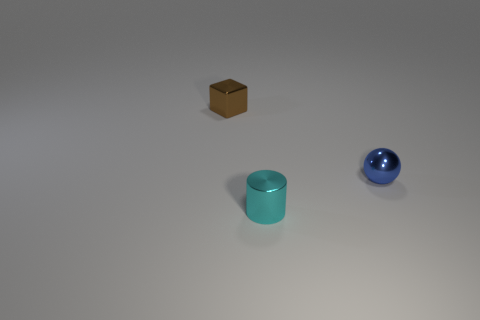How many blocks are either tiny red shiny things or cyan shiny objects?
Offer a very short reply. 0. There is a thing on the left side of the small object in front of the thing that is to the right of the tiny cyan metallic cylinder; what shape is it?
Offer a very short reply. Cube. What number of objects are the same size as the brown metal cube?
Your response must be concise. 2. Is there a tiny shiny ball in front of the tiny metal thing behind the tiny blue shiny thing?
Your response must be concise. Yes. How many things are either cylinders or blue metal spheres?
Your answer should be compact. 2. What is the color of the tiny object left of the object that is in front of the small object right of the small cyan metallic object?
Your response must be concise. Brown. What number of things are metal things behind the metal sphere or small metal things on the left side of the small blue metallic object?
Ensure brevity in your answer.  2. How many other things are the same material as the cylinder?
Offer a terse response. 2. Do the tiny cyan thing and the small brown shiny object have the same shape?
Offer a terse response. No. Is the number of small brown things in front of the blue ball less than the number of brown shiny spheres?
Provide a succinct answer. No. 